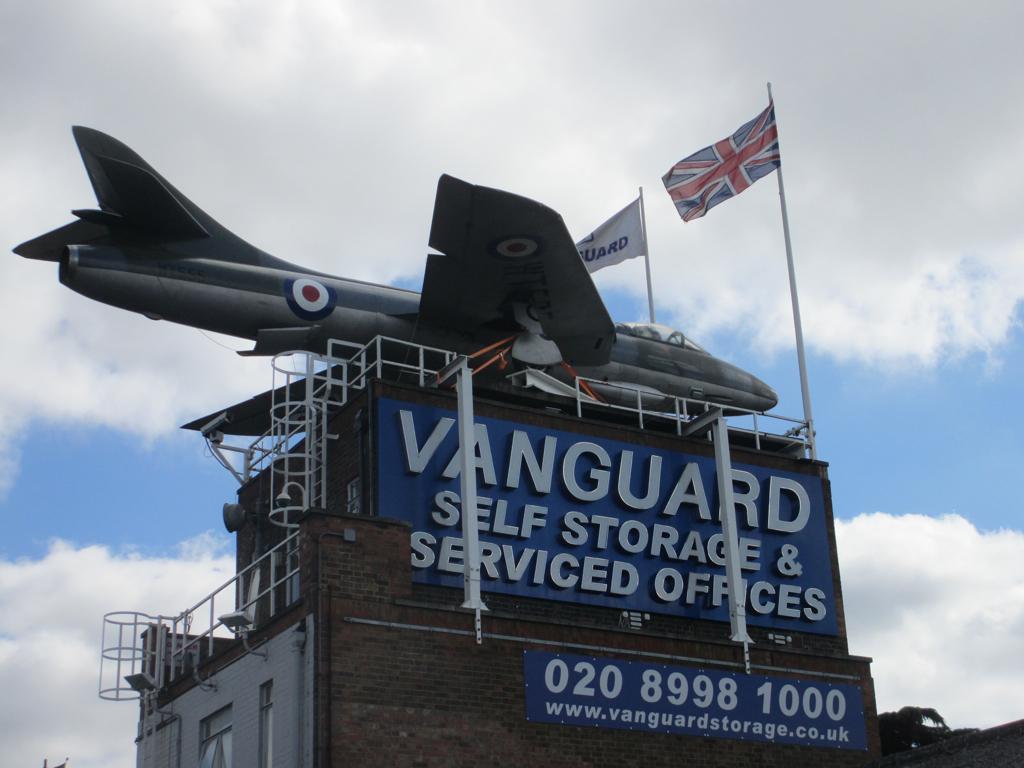In one or two sentences, can you explain what this image depicts? In the picture we can see an aircraft on the building and mentioned on the building wall as vanguard self storage and serviced offices and near the aircraft we can see two flags to the poles and in the background we can see the sky with clouds. 